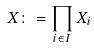<formula> <loc_0><loc_0><loc_500><loc_500>X \colon = \prod _ { i \in I } X _ { i }</formula> 